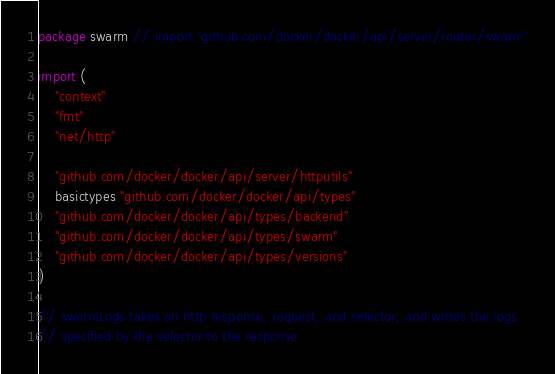Convert code to text. <code><loc_0><loc_0><loc_500><loc_500><_Go_>package swarm // import "github.com/docker/docker/api/server/router/swarm"

import (
	"context"
	"fmt"
	"net/http"

	"github.com/docker/docker/api/server/httputils"
	basictypes "github.com/docker/docker/api/types"
	"github.com/docker/docker/api/types/backend"
	"github.com/docker/docker/api/types/swarm"
	"github.com/docker/docker/api/types/versions"
)

// swarmLogs takes an http response, request, and selector, and writes the logs
// specified by the selector to the response</code> 